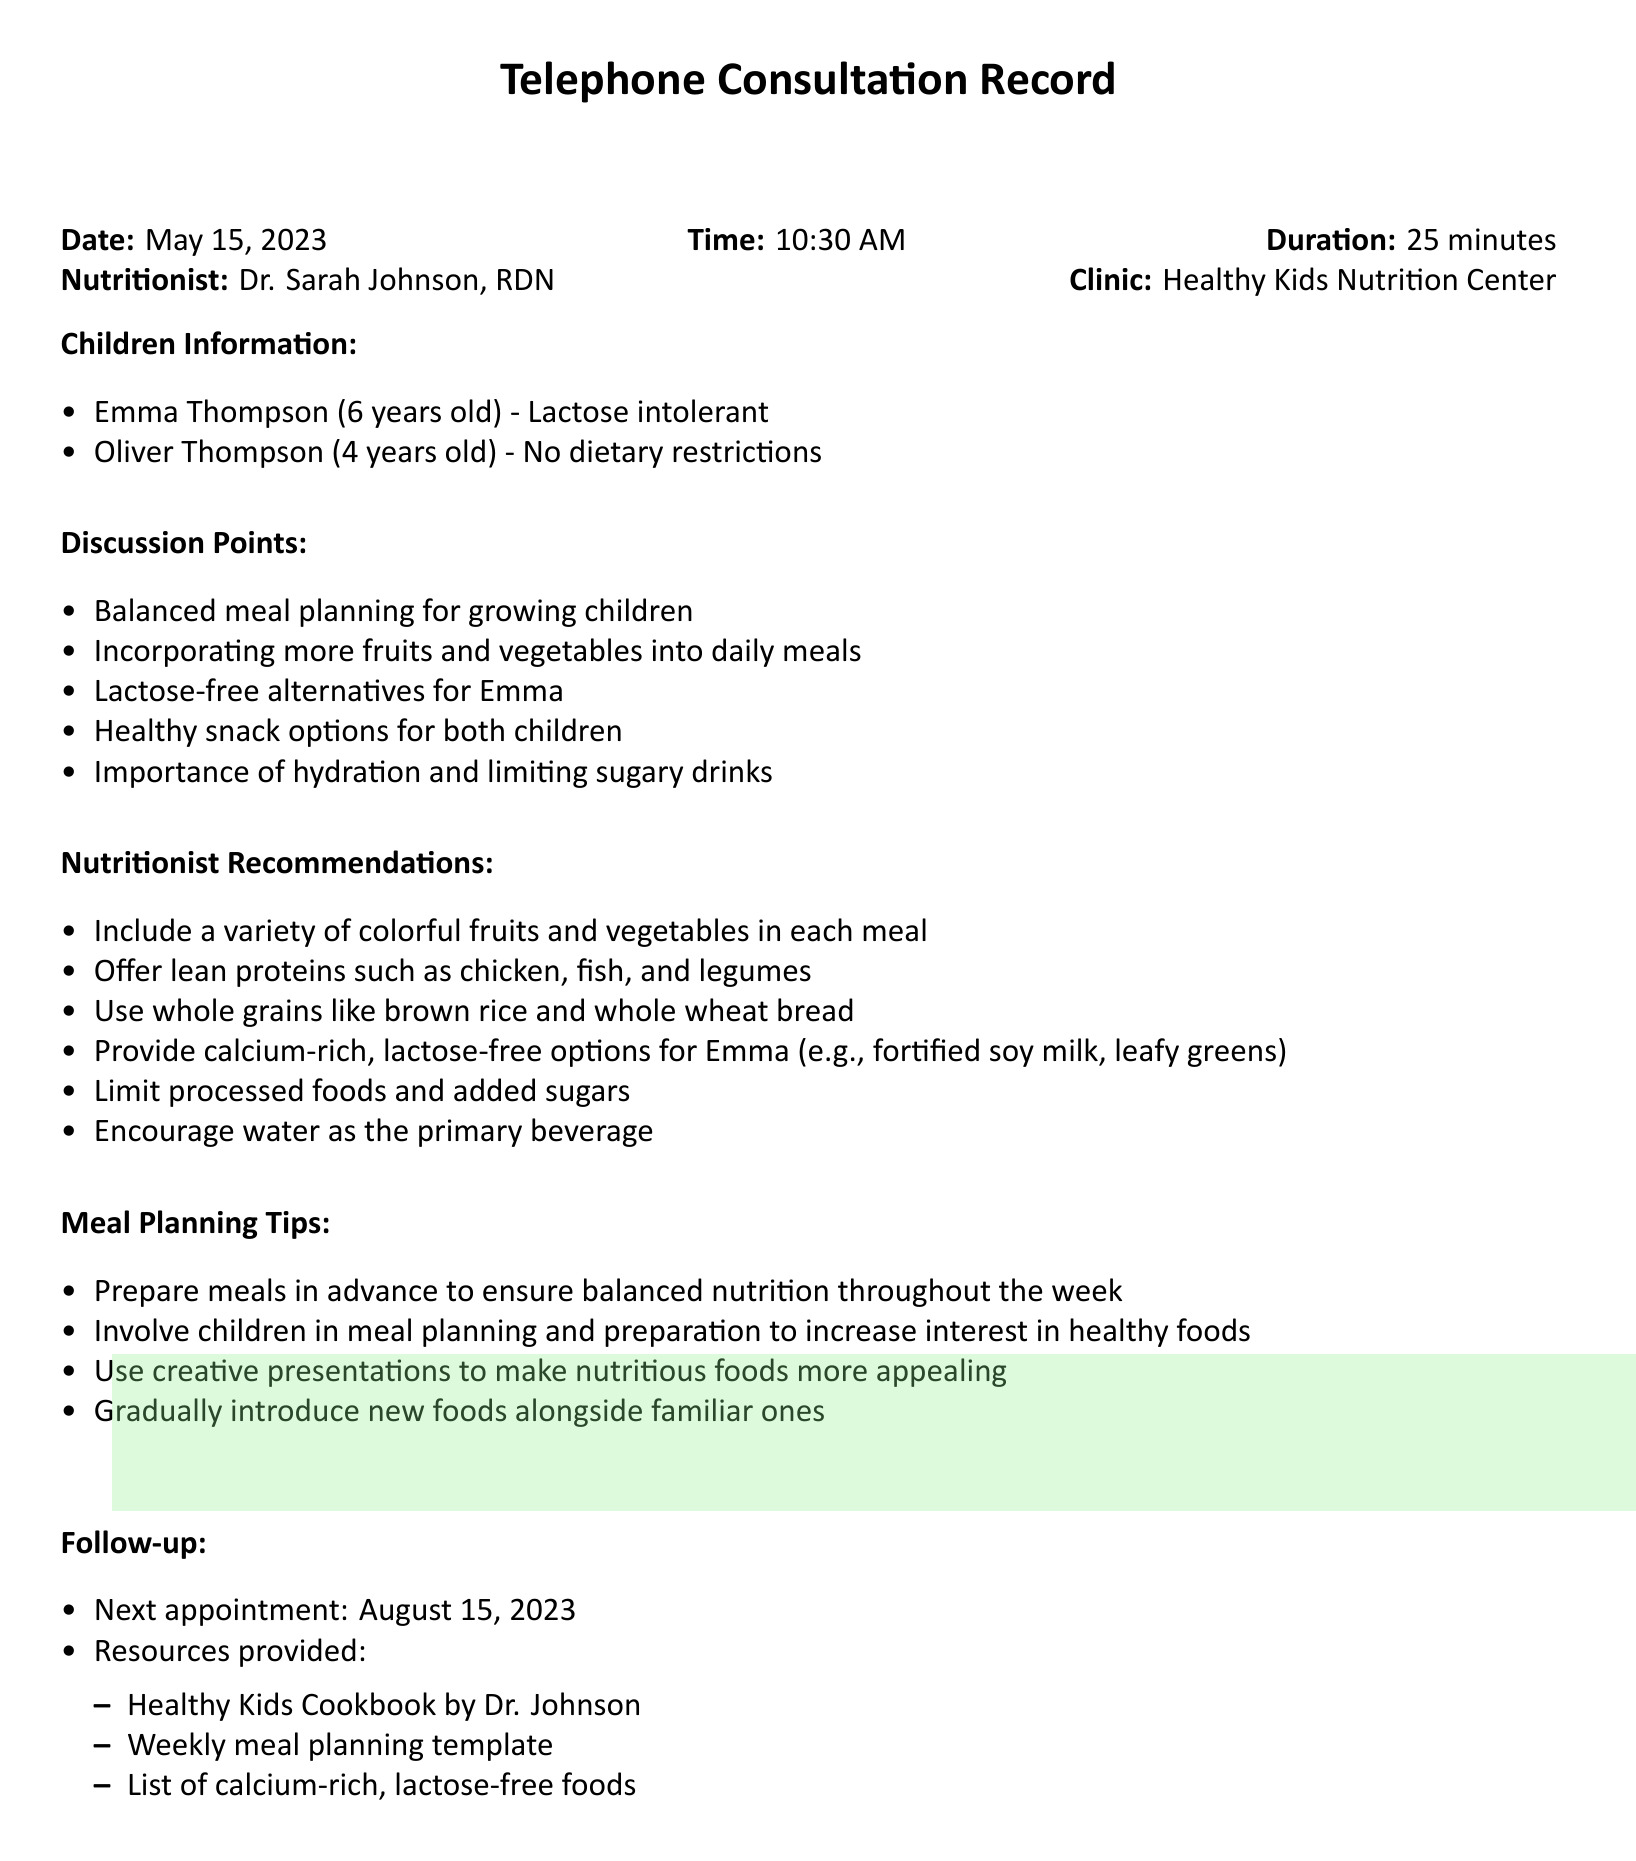What is the date of the consultation? The date is recorded at the beginning of the document under "Date."
Answer: May 15, 2023 Who is the nutritionist? The nutritionist's name is listed in the "Nutritionist" section of the document.
Answer: Dr. Sarah Johnson, RDN What are Emma's dietary restrictions? Emma's dietary restrictions are mentioned in the "Children Information" section.
Answer: Lactose intolerant What is one of the discussion points related to the meals? The discussion points are itemized in the "Discussion Points" section, indicating key topics covered.
Answer: Balanced meal planning for growing children What is recommended for Emma as a calcium-rich option? Recommendations for specific foods are provided in the "Nutritionist Recommendations" section.
Answer: Fortified soy milk When is the next appointment scheduled? The follow-up information includes the date of the next appointment.
Answer: August 15, 2023 What book was provided as a resource? The resources provided are listed in the "Follow-up" section of the document.
Answer: Healthy Kids Cookbook by Dr. Johnson What is a meal planning tip mentioned? Tips are outlined in the "Meal Planning Tips" section of the document.
Answer: Prepare meals in advance What is emphasized as the primary beverage? The recommendations highlight hydration in the "Nutritionist Recommendations" section.
Answer: Water 